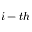<formula> <loc_0><loc_0><loc_500><loc_500>i - t h</formula> 